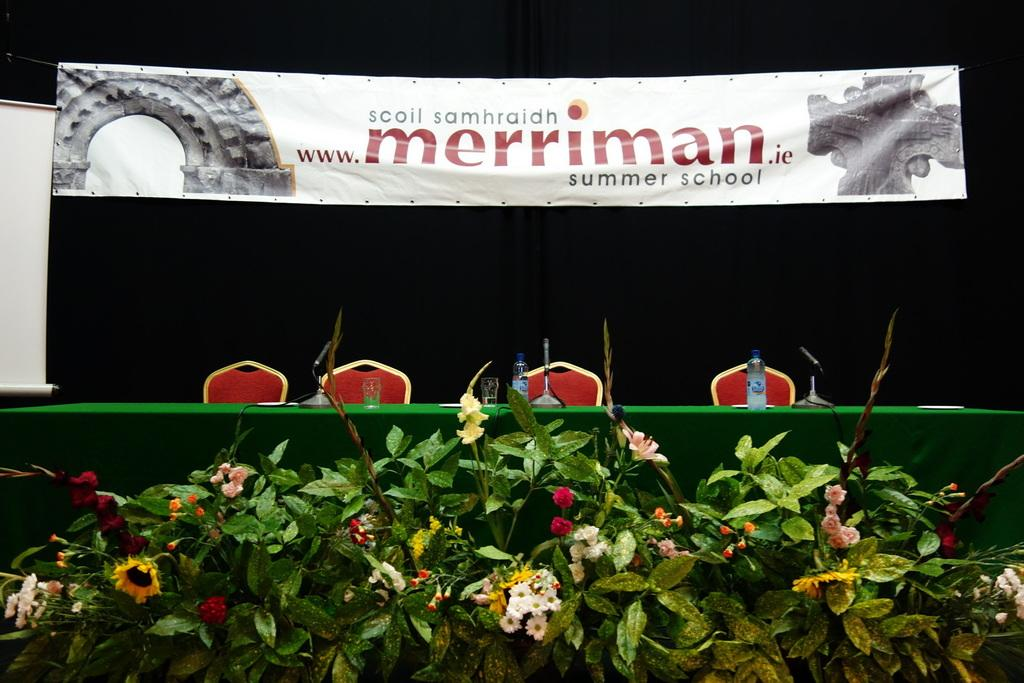What type of plants can be seen in the foreground of the image? There are flower plants in the foreground of the image. What objects are on the table in the image? There are bottles, glasses, and microphones on the table in the image. What can be seen in the background of the image? There are chairs, a poster, and a curtain in the background of the image. What type of wool is being used to create the elbow design on the poster in the background? There is no mention of wool or an elbow design in the image. The image features flower plants, bottles, glasses, microphones, chairs, a poster, and a curtain. 